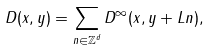Convert formula to latex. <formula><loc_0><loc_0><loc_500><loc_500>D ( x , y ) = \sum _ { n \in { \mathbb { Z } } ^ { d } } D ^ { \infty } ( x , y + L n ) ,</formula> 